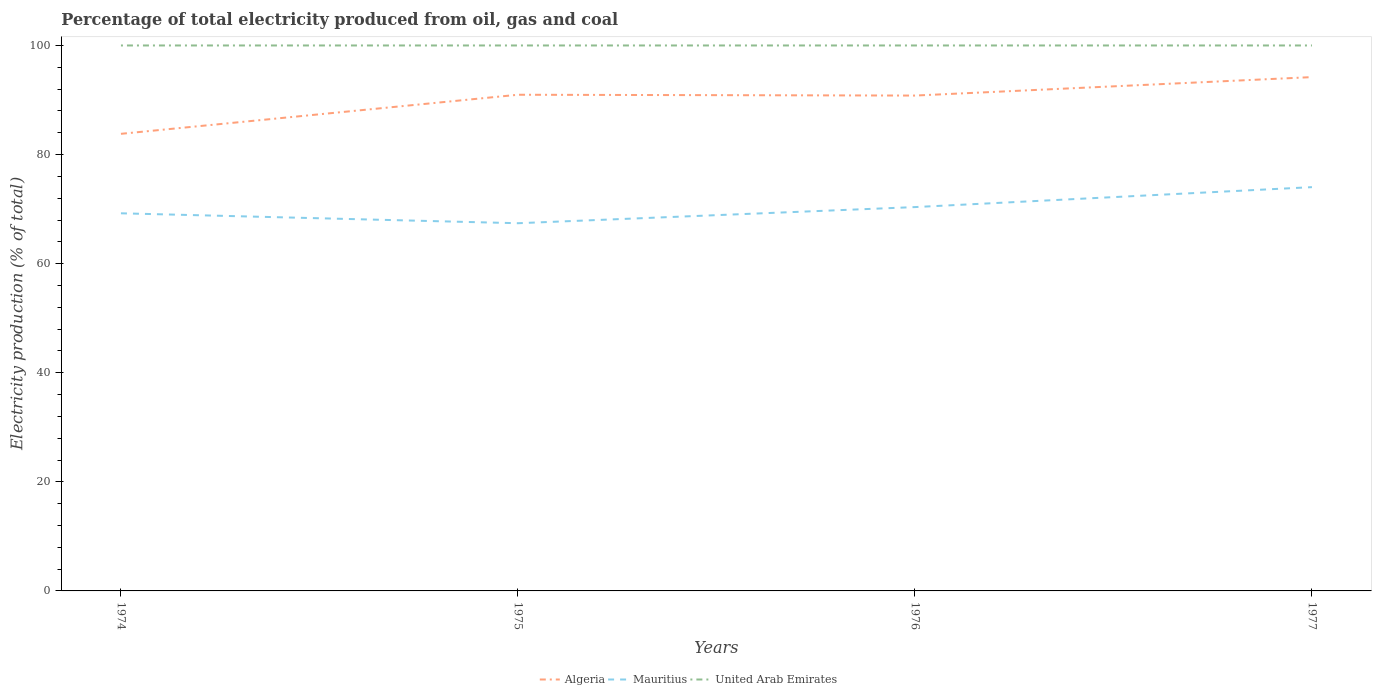How many different coloured lines are there?
Your answer should be compact. 3. Does the line corresponding to Mauritius intersect with the line corresponding to United Arab Emirates?
Offer a very short reply. No. Is the number of lines equal to the number of legend labels?
Keep it short and to the point. Yes. Across all years, what is the maximum electricity production in in Mauritius?
Ensure brevity in your answer.  67.41. In which year was the electricity production in in United Arab Emirates maximum?
Offer a very short reply. 1974. What is the total electricity production in in United Arab Emirates in the graph?
Your answer should be very brief. 0. What is the difference between the highest and the second highest electricity production in in Algeria?
Make the answer very short. 10.4. What is the difference between the highest and the lowest electricity production in in United Arab Emirates?
Offer a terse response. 0. Is the electricity production in in Mauritius strictly greater than the electricity production in in United Arab Emirates over the years?
Ensure brevity in your answer.  Yes. How many years are there in the graph?
Your answer should be compact. 4. Does the graph contain grids?
Give a very brief answer. No. Where does the legend appear in the graph?
Your response must be concise. Bottom center. How many legend labels are there?
Offer a very short reply. 3. How are the legend labels stacked?
Your answer should be very brief. Horizontal. What is the title of the graph?
Offer a terse response. Percentage of total electricity produced from oil, gas and coal. What is the label or title of the X-axis?
Ensure brevity in your answer.  Years. What is the label or title of the Y-axis?
Give a very brief answer. Electricity production (% of total). What is the Electricity production (% of total) in Algeria in 1974?
Give a very brief answer. 83.8. What is the Electricity production (% of total) of Mauritius in 1974?
Make the answer very short. 69.23. What is the Electricity production (% of total) in Algeria in 1975?
Offer a very short reply. 90.96. What is the Electricity production (% of total) of Mauritius in 1975?
Ensure brevity in your answer.  67.41. What is the Electricity production (% of total) in United Arab Emirates in 1975?
Ensure brevity in your answer.  100. What is the Electricity production (% of total) of Algeria in 1976?
Offer a very short reply. 90.81. What is the Electricity production (% of total) in Mauritius in 1976?
Ensure brevity in your answer.  70.37. What is the Electricity production (% of total) of United Arab Emirates in 1976?
Your response must be concise. 100. What is the Electricity production (% of total) of Algeria in 1977?
Provide a short and direct response. 94.2. What is the Electricity production (% of total) in Mauritius in 1977?
Ensure brevity in your answer.  74.03. Across all years, what is the maximum Electricity production (% of total) of Algeria?
Make the answer very short. 94.2. Across all years, what is the maximum Electricity production (% of total) of Mauritius?
Your answer should be very brief. 74.03. Across all years, what is the maximum Electricity production (% of total) in United Arab Emirates?
Offer a terse response. 100. Across all years, what is the minimum Electricity production (% of total) of Algeria?
Keep it short and to the point. 83.8. Across all years, what is the minimum Electricity production (% of total) in Mauritius?
Your answer should be compact. 67.41. Across all years, what is the minimum Electricity production (% of total) of United Arab Emirates?
Offer a terse response. 100. What is the total Electricity production (% of total) of Algeria in the graph?
Provide a short and direct response. 359.78. What is the total Electricity production (% of total) of Mauritius in the graph?
Offer a very short reply. 281.04. What is the total Electricity production (% of total) of United Arab Emirates in the graph?
Your response must be concise. 400. What is the difference between the Electricity production (% of total) in Algeria in 1974 and that in 1975?
Provide a short and direct response. -7.16. What is the difference between the Electricity production (% of total) of Mauritius in 1974 and that in 1975?
Give a very brief answer. 1.82. What is the difference between the Electricity production (% of total) of Algeria in 1974 and that in 1976?
Provide a succinct answer. -7.01. What is the difference between the Electricity production (% of total) in Mauritius in 1974 and that in 1976?
Provide a succinct answer. -1.14. What is the difference between the Electricity production (% of total) of United Arab Emirates in 1974 and that in 1976?
Provide a succinct answer. 0. What is the difference between the Electricity production (% of total) in Algeria in 1974 and that in 1977?
Your answer should be very brief. -10.4. What is the difference between the Electricity production (% of total) of Mauritius in 1974 and that in 1977?
Provide a short and direct response. -4.8. What is the difference between the Electricity production (% of total) in United Arab Emirates in 1974 and that in 1977?
Offer a very short reply. 0. What is the difference between the Electricity production (% of total) in Algeria in 1975 and that in 1976?
Your answer should be very brief. 0.15. What is the difference between the Electricity production (% of total) in Mauritius in 1975 and that in 1976?
Make the answer very short. -2.96. What is the difference between the Electricity production (% of total) in United Arab Emirates in 1975 and that in 1976?
Provide a succinct answer. 0. What is the difference between the Electricity production (% of total) of Algeria in 1975 and that in 1977?
Keep it short and to the point. -3.23. What is the difference between the Electricity production (% of total) in Mauritius in 1975 and that in 1977?
Keep it short and to the point. -6.62. What is the difference between the Electricity production (% of total) of Algeria in 1976 and that in 1977?
Offer a very short reply. -3.38. What is the difference between the Electricity production (% of total) of Mauritius in 1976 and that in 1977?
Offer a very short reply. -3.66. What is the difference between the Electricity production (% of total) of United Arab Emirates in 1976 and that in 1977?
Offer a very short reply. 0. What is the difference between the Electricity production (% of total) in Algeria in 1974 and the Electricity production (% of total) in Mauritius in 1975?
Ensure brevity in your answer.  16.39. What is the difference between the Electricity production (% of total) in Algeria in 1974 and the Electricity production (% of total) in United Arab Emirates in 1975?
Provide a short and direct response. -16.2. What is the difference between the Electricity production (% of total) of Mauritius in 1974 and the Electricity production (% of total) of United Arab Emirates in 1975?
Provide a succinct answer. -30.77. What is the difference between the Electricity production (% of total) in Algeria in 1974 and the Electricity production (% of total) in Mauritius in 1976?
Your answer should be very brief. 13.43. What is the difference between the Electricity production (% of total) of Algeria in 1974 and the Electricity production (% of total) of United Arab Emirates in 1976?
Your response must be concise. -16.2. What is the difference between the Electricity production (% of total) in Mauritius in 1974 and the Electricity production (% of total) in United Arab Emirates in 1976?
Your answer should be compact. -30.77. What is the difference between the Electricity production (% of total) in Algeria in 1974 and the Electricity production (% of total) in Mauritius in 1977?
Ensure brevity in your answer.  9.77. What is the difference between the Electricity production (% of total) in Algeria in 1974 and the Electricity production (% of total) in United Arab Emirates in 1977?
Keep it short and to the point. -16.2. What is the difference between the Electricity production (% of total) in Mauritius in 1974 and the Electricity production (% of total) in United Arab Emirates in 1977?
Ensure brevity in your answer.  -30.77. What is the difference between the Electricity production (% of total) in Algeria in 1975 and the Electricity production (% of total) in Mauritius in 1976?
Your answer should be compact. 20.59. What is the difference between the Electricity production (% of total) in Algeria in 1975 and the Electricity production (% of total) in United Arab Emirates in 1976?
Give a very brief answer. -9.04. What is the difference between the Electricity production (% of total) of Mauritius in 1975 and the Electricity production (% of total) of United Arab Emirates in 1976?
Your response must be concise. -32.59. What is the difference between the Electricity production (% of total) of Algeria in 1975 and the Electricity production (% of total) of Mauritius in 1977?
Offer a very short reply. 16.94. What is the difference between the Electricity production (% of total) in Algeria in 1975 and the Electricity production (% of total) in United Arab Emirates in 1977?
Your answer should be very brief. -9.04. What is the difference between the Electricity production (% of total) of Mauritius in 1975 and the Electricity production (% of total) of United Arab Emirates in 1977?
Your answer should be very brief. -32.59. What is the difference between the Electricity production (% of total) in Algeria in 1976 and the Electricity production (% of total) in Mauritius in 1977?
Your answer should be compact. 16.79. What is the difference between the Electricity production (% of total) in Algeria in 1976 and the Electricity production (% of total) in United Arab Emirates in 1977?
Offer a terse response. -9.19. What is the difference between the Electricity production (% of total) of Mauritius in 1976 and the Electricity production (% of total) of United Arab Emirates in 1977?
Your answer should be very brief. -29.63. What is the average Electricity production (% of total) of Algeria per year?
Ensure brevity in your answer.  89.94. What is the average Electricity production (% of total) of Mauritius per year?
Your answer should be compact. 70.26. In the year 1974, what is the difference between the Electricity production (% of total) in Algeria and Electricity production (% of total) in Mauritius?
Your answer should be very brief. 14.57. In the year 1974, what is the difference between the Electricity production (% of total) in Algeria and Electricity production (% of total) in United Arab Emirates?
Make the answer very short. -16.2. In the year 1974, what is the difference between the Electricity production (% of total) in Mauritius and Electricity production (% of total) in United Arab Emirates?
Keep it short and to the point. -30.77. In the year 1975, what is the difference between the Electricity production (% of total) in Algeria and Electricity production (% of total) in Mauritius?
Ensure brevity in your answer.  23.55. In the year 1975, what is the difference between the Electricity production (% of total) in Algeria and Electricity production (% of total) in United Arab Emirates?
Provide a short and direct response. -9.04. In the year 1975, what is the difference between the Electricity production (% of total) in Mauritius and Electricity production (% of total) in United Arab Emirates?
Your answer should be compact. -32.59. In the year 1976, what is the difference between the Electricity production (% of total) in Algeria and Electricity production (% of total) in Mauritius?
Offer a terse response. 20.44. In the year 1976, what is the difference between the Electricity production (% of total) in Algeria and Electricity production (% of total) in United Arab Emirates?
Offer a terse response. -9.19. In the year 1976, what is the difference between the Electricity production (% of total) of Mauritius and Electricity production (% of total) of United Arab Emirates?
Offer a terse response. -29.63. In the year 1977, what is the difference between the Electricity production (% of total) of Algeria and Electricity production (% of total) of Mauritius?
Provide a succinct answer. 20.17. In the year 1977, what is the difference between the Electricity production (% of total) of Algeria and Electricity production (% of total) of United Arab Emirates?
Make the answer very short. -5.8. In the year 1977, what is the difference between the Electricity production (% of total) of Mauritius and Electricity production (% of total) of United Arab Emirates?
Your answer should be compact. -25.97. What is the ratio of the Electricity production (% of total) of Algeria in 1974 to that in 1975?
Provide a short and direct response. 0.92. What is the ratio of the Electricity production (% of total) in Mauritius in 1974 to that in 1975?
Offer a very short reply. 1.03. What is the ratio of the Electricity production (% of total) in Algeria in 1974 to that in 1976?
Give a very brief answer. 0.92. What is the ratio of the Electricity production (% of total) in Mauritius in 1974 to that in 1976?
Offer a terse response. 0.98. What is the ratio of the Electricity production (% of total) of Algeria in 1974 to that in 1977?
Your answer should be very brief. 0.89. What is the ratio of the Electricity production (% of total) of Mauritius in 1974 to that in 1977?
Provide a succinct answer. 0.94. What is the ratio of the Electricity production (% of total) of Mauritius in 1975 to that in 1976?
Your response must be concise. 0.96. What is the ratio of the Electricity production (% of total) of Algeria in 1975 to that in 1977?
Your answer should be very brief. 0.97. What is the ratio of the Electricity production (% of total) in Mauritius in 1975 to that in 1977?
Your answer should be compact. 0.91. What is the ratio of the Electricity production (% of total) of Algeria in 1976 to that in 1977?
Keep it short and to the point. 0.96. What is the ratio of the Electricity production (% of total) of Mauritius in 1976 to that in 1977?
Offer a terse response. 0.95. What is the difference between the highest and the second highest Electricity production (% of total) in Algeria?
Keep it short and to the point. 3.23. What is the difference between the highest and the second highest Electricity production (% of total) of Mauritius?
Offer a very short reply. 3.66. What is the difference between the highest and the lowest Electricity production (% of total) in Algeria?
Your answer should be very brief. 10.4. What is the difference between the highest and the lowest Electricity production (% of total) of Mauritius?
Offer a terse response. 6.62. 